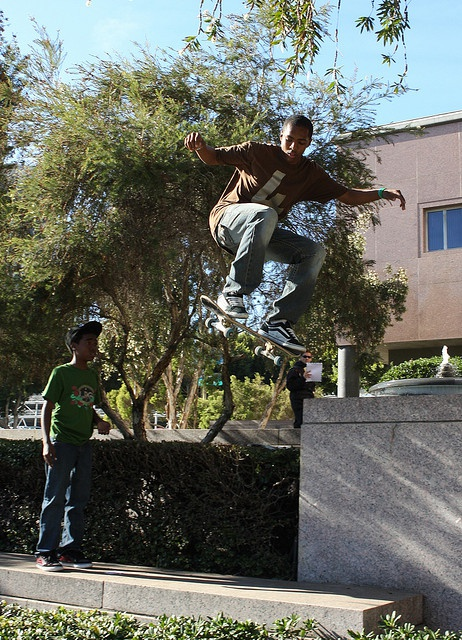Describe the objects in this image and their specific colors. I can see people in lightblue, black, gray, ivory, and maroon tones, people in lightblue, black, gray, darkgray, and ivory tones, and skateboard in lightblue, black, ivory, gray, and darkgray tones in this image. 